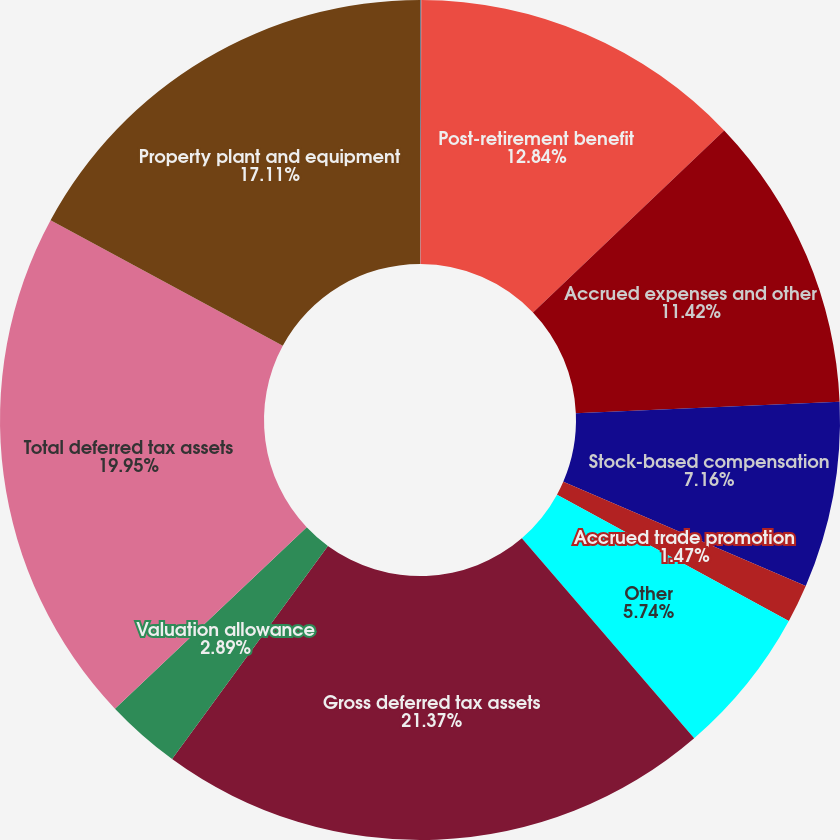Convert chart. <chart><loc_0><loc_0><loc_500><loc_500><pie_chart><fcel>December 31<fcel>Post-retirement benefit<fcel>Accrued expenses and other<fcel>Stock-based compensation<fcel>Accrued trade promotion<fcel>Other<fcel>Gross deferred tax assets<fcel>Valuation allowance<fcel>Total deferred tax assets<fcel>Property plant and equipment<nl><fcel>0.05%<fcel>12.84%<fcel>11.42%<fcel>7.16%<fcel>1.47%<fcel>5.74%<fcel>21.37%<fcel>2.89%<fcel>19.95%<fcel>17.11%<nl></chart> 